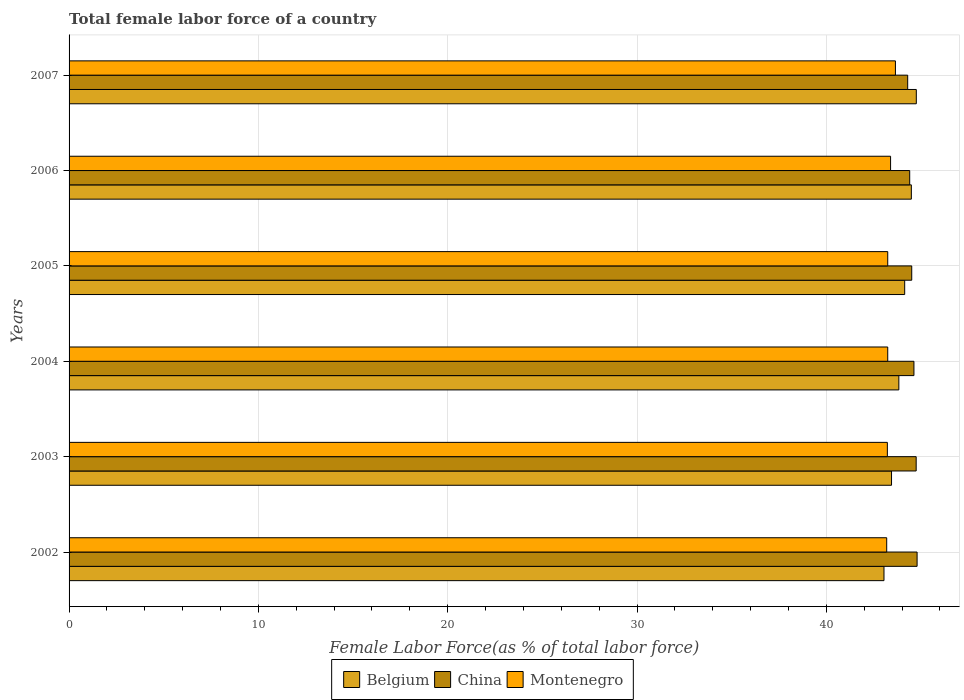How many different coloured bars are there?
Your answer should be very brief. 3. How many bars are there on the 1st tick from the bottom?
Offer a terse response. 3. What is the label of the 4th group of bars from the top?
Your response must be concise. 2004. In how many cases, is the number of bars for a given year not equal to the number of legend labels?
Your response must be concise. 0. What is the percentage of female labor force in China in 2002?
Your answer should be compact. 44.79. Across all years, what is the maximum percentage of female labor force in China?
Keep it short and to the point. 44.79. Across all years, what is the minimum percentage of female labor force in China?
Your answer should be compact. 44.3. In which year was the percentage of female labor force in Montenegro maximum?
Offer a terse response. 2007. In which year was the percentage of female labor force in Montenegro minimum?
Your answer should be very brief. 2002. What is the total percentage of female labor force in Montenegro in the graph?
Give a very brief answer. 259.93. What is the difference between the percentage of female labor force in Belgium in 2006 and that in 2007?
Offer a very short reply. -0.26. What is the difference between the percentage of female labor force in China in 2005 and the percentage of female labor force in Belgium in 2007?
Provide a succinct answer. -0.24. What is the average percentage of female labor force in China per year?
Your response must be concise. 44.56. In the year 2007, what is the difference between the percentage of female labor force in Montenegro and percentage of female labor force in Belgium?
Your response must be concise. -1.1. In how many years, is the percentage of female labor force in Belgium greater than 38 %?
Keep it short and to the point. 6. What is the ratio of the percentage of female labor force in Montenegro in 2002 to that in 2003?
Offer a very short reply. 1. What is the difference between the highest and the second highest percentage of female labor force in Belgium?
Offer a very short reply. 0.26. What is the difference between the highest and the lowest percentage of female labor force in Belgium?
Your answer should be very brief. 1.71. What does the 3rd bar from the top in 2006 represents?
Give a very brief answer. Belgium. How many bars are there?
Your response must be concise. 18. Are all the bars in the graph horizontal?
Make the answer very short. Yes. How many years are there in the graph?
Your answer should be very brief. 6. Are the values on the major ticks of X-axis written in scientific E-notation?
Ensure brevity in your answer.  No. How are the legend labels stacked?
Your answer should be compact. Horizontal. What is the title of the graph?
Make the answer very short. Total female labor force of a country. What is the label or title of the X-axis?
Give a very brief answer. Female Labor Force(as % of total labor force). What is the Female Labor Force(as % of total labor force) in Belgium in 2002?
Your response must be concise. 43.04. What is the Female Labor Force(as % of total labor force) of China in 2002?
Ensure brevity in your answer.  44.79. What is the Female Labor Force(as % of total labor force) in Montenegro in 2002?
Offer a very short reply. 43.19. What is the Female Labor Force(as % of total labor force) in Belgium in 2003?
Make the answer very short. 43.44. What is the Female Labor Force(as % of total labor force) of China in 2003?
Offer a terse response. 44.74. What is the Female Labor Force(as % of total labor force) of Montenegro in 2003?
Provide a short and direct response. 43.22. What is the Female Labor Force(as % of total labor force) in Belgium in 2004?
Make the answer very short. 43.83. What is the Female Labor Force(as % of total labor force) in China in 2004?
Provide a succinct answer. 44.63. What is the Female Labor Force(as % of total labor force) in Montenegro in 2004?
Ensure brevity in your answer.  43.24. What is the Female Labor Force(as % of total labor force) in Belgium in 2005?
Offer a terse response. 44.14. What is the Female Labor Force(as % of total labor force) in China in 2005?
Keep it short and to the point. 44.51. What is the Female Labor Force(as % of total labor force) of Montenegro in 2005?
Give a very brief answer. 43.24. What is the Female Labor Force(as % of total labor force) in Belgium in 2006?
Give a very brief answer. 44.49. What is the Female Labor Force(as % of total labor force) in China in 2006?
Provide a succinct answer. 44.4. What is the Female Labor Force(as % of total labor force) of Montenegro in 2006?
Your response must be concise. 43.39. What is the Female Labor Force(as % of total labor force) in Belgium in 2007?
Your answer should be compact. 44.75. What is the Female Labor Force(as % of total labor force) of China in 2007?
Your answer should be very brief. 44.3. What is the Female Labor Force(as % of total labor force) of Montenegro in 2007?
Provide a succinct answer. 43.65. Across all years, what is the maximum Female Labor Force(as % of total labor force) of Belgium?
Make the answer very short. 44.75. Across all years, what is the maximum Female Labor Force(as % of total labor force) in China?
Make the answer very short. 44.79. Across all years, what is the maximum Female Labor Force(as % of total labor force) in Montenegro?
Your answer should be very brief. 43.65. Across all years, what is the minimum Female Labor Force(as % of total labor force) of Belgium?
Your answer should be very brief. 43.04. Across all years, what is the minimum Female Labor Force(as % of total labor force) in China?
Keep it short and to the point. 44.3. Across all years, what is the minimum Female Labor Force(as % of total labor force) in Montenegro?
Provide a short and direct response. 43.19. What is the total Female Labor Force(as % of total labor force) of Belgium in the graph?
Give a very brief answer. 263.69. What is the total Female Labor Force(as % of total labor force) in China in the graph?
Provide a succinct answer. 267.37. What is the total Female Labor Force(as % of total labor force) of Montenegro in the graph?
Offer a very short reply. 259.93. What is the difference between the Female Labor Force(as % of total labor force) of Belgium in 2002 and that in 2003?
Offer a very short reply. -0.4. What is the difference between the Female Labor Force(as % of total labor force) of China in 2002 and that in 2003?
Keep it short and to the point. 0.05. What is the difference between the Female Labor Force(as % of total labor force) in Montenegro in 2002 and that in 2003?
Provide a short and direct response. -0.04. What is the difference between the Female Labor Force(as % of total labor force) in Belgium in 2002 and that in 2004?
Provide a succinct answer. -0.78. What is the difference between the Female Labor Force(as % of total labor force) of China in 2002 and that in 2004?
Your answer should be very brief. 0.17. What is the difference between the Female Labor Force(as % of total labor force) of Montenegro in 2002 and that in 2004?
Provide a succinct answer. -0.06. What is the difference between the Female Labor Force(as % of total labor force) in Belgium in 2002 and that in 2005?
Your answer should be very brief. -1.09. What is the difference between the Female Labor Force(as % of total labor force) in China in 2002 and that in 2005?
Provide a succinct answer. 0.28. What is the difference between the Female Labor Force(as % of total labor force) in Montenegro in 2002 and that in 2005?
Make the answer very short. -0.06. What is the difference between the Female Labor Force(as % of total labor force) of Belgium in 2002 and that in 2006?
Offer a very short reply. -1.45. What is the difference between the Female Labor Force(as % of total labor force) of China in 2002 and that in 2006?
Provide a short and direct response. 0.39. What is the difference between the Female Labor Force(as % of total labor force) of Montenegro in 2002 and that in 2006?
Give a very brief answer. -0.21. What is the difference between the Female Labor Force(as % of total labor force) in Belgium in 2002 and that in 2007?
Provide a short and direct response. -1.71. What is the difference between the Female Labor Force(as % of total labor force) of China in 2002 and that in 2007?
Offer a terse response. 0.5. What is the difference between the Female Labor Force(as % of total labor force) of Montenegro in 2002 and that in 2007?
Your response must be concise. -0.46. What is the difference between the Female Labor Force(as % of total labor force) in Belgium in 2003 and that in 2004?
Ensure brevity in your answer.  -0.39. What is the difference between the Female Labor Force(as % of total labor force) in China in 2003 and that in 2004?
Your answer should be very brief. 0.12. What is the difference between the Female Labor Force(as % of total labor force) in Montenegro in 2003 and that in 2004?
Offer a terse response. -0.02. What is the difference between the Female Labor Force(as % of total labor force) of Belgium in 2003 and that in 2005?
Ensure brevity in your answer.  -0.69. What is the difference between the Female Labor Force(as % of total labor force) of China in 2003 and that in 2005?
Provide a short and direct response. 0.23. What is the difference between the Female Labor Force(as % of total labor force) in Montenegro in 2003 and that in 2005?
Give a very brief answer. -0.02. What is the difference between the Female Labor Force(as % of total labor force) of Belgium in 2003 and that in 2006?
Your answer should be compact. -1.05. What is the difference between the Female Labor Force(as % of total labor force) in China in 2003 and that in 2006?
Ensure brevity in your answer.  0.34. What is the difference between the Female Labor Force(as % of total labor force) of Montenegro in 2003 and that in 2006?
Ensure brevity in your answer.  -0.17. What is the difference between the Female Labor Force(as % of total labor force) of Belgium in 2003 and that in 2007?
Provide a short and direct response. -1.31. What is the difference between the Female Labor Force(as % of total labor force) of China in 2003 and that in 2007?
Provide a short and direct response. 0.45. What is the difference between the Female Labor Force(as % of total labor force) of Montenegro in 2003 and that in 2007?
Your answer should be very brief. -0.43. What is the difference between the Female Labor Force(as % of total labor force) in Belgium in 2004 and that in 2005?
Provide a succinct answer. -0.31. What is the difference between the Female Labor Force(as % of total labor force) of China in 2004 and that in 2005?
Offer a very short reply. 0.12. What is the difference between the Female Labor Force(as % of total labor force) of Belgium in 2004 and that in 2006?
Make the answer very short. -0.66. What is the difference between the Female Labor Force(as % of total labor force) of China in 2004 and that in 2006?
Make the answer very short. 0.22. What is the difference between the Female Labor Force(as % of total labor force) in Montenegro in 2004 and that in 2006?
Offer a very short reply. -0.15. What is the difference between the Female Labor Force(as % of total labor force) of Belgium in 2004 and that in 2007?
Keep it short and to the point. -0.92. What is the difference between the Female Labor Force(as % of total labor force) of China in 2004 and that in 2007?
Provide a succinct answer. 0.33. What is the difference between the Female Labor Force(as % of total labor force) of Montenegro in 2004 and that in 2007?
Give a very brief answer. -0.41. What is the difference between the Female Labor Force(as % of total labor force) in Belgium in 2005 and that in 2006?
Give a very brief answer. -0.35. What is the difference between the Female Labor Force(as % of total labor force) in China in 2005 and that in 2006?
Keep it short and to the point. 0.11. What is the difference between the Female Labor Force(as % of total labor force) of Montenegro in 2005 and that in 2006?
Provide a short and direct response. -0.15. What is the difference between the Female Labor Force(as % of total labor force) in Belgium in 2005 and that in 2007?
Your answer should be compact. -0.61. What is the difference between the Female Labor Force(as % of total labor force) in China in 2005 and that in 2007?
Keep it short and to the point. 0.21. What is the difference between the Female Labor Force(as % of total labor force) of Montenegro in 2005 and that in 2007?
Your answer should be very brief. -0.41. What is the difference between the Female Labor Force(as % of total labor force) of Belgium in 2006 and that in 2007?
Provide a succinct answer. -0.26. What is the difference between the Female Labor Force(as % of total labor force) of China in 2006 and that in 2007?
Provide a short and direct response. 0.11. What is the difference between the Female Labor Force(as % of total labor force) of Montenegro in 2006 and that in 2007?
Ensure brevity in your answer.  -0.26. What is the difference between the Female Labor Force(as % of total labor force) in Belgium in 2002 and the Female Labor Force(as % of total labor force) in China in 2003?
Your answer should be very brief. -1.7. What is the difference between the Female Labor Force(as % of total labor force) of Belgium in 2002 and the Female Labor Force(as % of total labor force) of Montenegro in 2003?
Ensure brevity in your answer.  -0.18. What is the difference between the Female Labor Force(as % of total labor force) of China in 2002 and the Female Labor Force(as % of total labor force) of Montenegro in 2003?
Your response must be concise. 1.57. What is the difference between the Female Labor Force(as % of total labor force) in Belgium in 2002 and the Female Labor Force(as % of total labor force) in China in 2004?
Ensure brevity in your answer.  -1.58. What is the difference between the Female Labor Force(as % of total labor force) of Belgium in 2002 and the Female Labor Force(as % of total labor force) of Montenegro in 2004?
Ensure brevity in your answer.  -0.2. What is the difference between the Female Labor Force(as % of total labor force) of China in 2002 and the Female Labor Force(as % of total labor force) of Montenegro in 2004?
Give a very brief answer. 1.55. What is the difference between the Female Labor Force(as % of total labor force) of Belgium in 2002 and the Female Labor Force(as % of total labor force) of China in 2005?
Your answer should be very brief. -1.47. What is the difference between the Female Labor Force(as % of total labor force) of Belgium in 2002 and the Female Labor Force(as % of total labor force) of Montenegro in 2005?
Your response must be concise. -0.2. What is the difference between the Female Labor Force(as % of total labor force) in China in 2002 and the Female Labor Force(as % of total labor force) in Montenegro in 2005?
Offer a terse response. 1.55. What is the difference between the Female Labor Force(as % of total labor force) in Belgium in 2002 and the Female Labor Force(as % of total labor force) in China in 2006?
Your response must be concise. -1.36. What is the difference between the Female Labor Force(as % of total labor force) in Belgium in 2002 and the Female Labor Force(as % of total labor force) in Montenegro in 2006?
Keep it short and to the point. -0.35. What is the difference between the Female Labor Force(as % of total labor force) of Belgium in 2002 and the Female Labor Force(as % of total labor force) of China in 2007?
Ensure brevity in your answer.  -1.25. What is the difference between the Female Labor Force(as % of total labor force) of Belgium in 2002 and the Female Labor Force(as % of total labor force) of Montenegro in 2007?
Keep it short and to the point. -0.6. What is the difference between the Female Labor Force(as % of total labor force) in China in 2002 and the Female Labor Force(as % of total labor force) in Montenegro in 2007?
Give a very brief answer. 1.14. What is the difference between the Female Labor Force(as % of total labor force) of Belgium in 2003 and the Female Labor Force(as % of total labor force) of China in 2004?
Offer a terse response. -1.18. What is the difference between the Female Labor Force(as % of total labor force) in Belgium in 2003 and the Female Labor Force(as % of total labor force) in Montenegro in 2004?
Give a very brief answer. 0.2. What is the difference between the Female Labor Force(as % of total labor force) of China in 2003 and the Female Labor Force(as % of total labor force) of Montenegro in 2004?
Ensure brevity in your answer.  1.5. What is the difference between the Female Labor Force(as % of total labor force) in Belgium in 2003 and the Female Labor Force(as % of total labor force) in China in 2005?
Ensure brevity in your answer.  -1.07. What is the difference between the Female Labor Force(as % of total labor force) in Belgium in 2003 and the Female Labor Force(as % of total labor force) in Montenegro in 2005?
Your answer should be compact. 0.2. What is the difference between the Female Labor Force(as % of total labor force) in China in 2003 and the Female Labor Force(as % of total labor force) in Montenegro in 2005?
Give a very brief answer. 1.5. What is the difference between the Female Labor Force(as % of total labor force) in Belgium in 2003 and the Female Labor Force(as % of total labor force) in China in 2006?
Make the answer very short. -0.96. What is the difference between the Female Labor Force(as % of total labor force) in Belgium in 2003 and the Female Labor Force(as % of total labor force) in Montenegro in 2006?
Give a very brief answer. 0.05. What is the difference between the Female Labor Force(as % of total labor force) in China in 2003 and the Female Labor Force(as % of total labor force) in Montenegro in 2006?
Keep it short and to the point. 1.35. What is the difference between the Female Labor Force(as % of total labor force) of Belgium in 2003 and the Female Labor Force(as % of total labor force) of China in 2007?
Your answer should be compact. -0.85. What is the difference between the Female Labor Force(as % of total labor force) in Belgium in 2003 and the Female Labor Force(as % of total labor force) in Montenegro in 2007?
Give a very brief answer. -0.21. What is the difference between the Female Labor Force(as % of total labor force) in China in 2003 and the Female Labor Force(as % of total labor force) in Montenegro in 2007?
Your answer should be compact. 1.1. What is the difference between the Female Labor Force(as % of total labor force) in Belgium in 2004 and the Female Labor Force(as % of total labor force) in China in 2005?
Keep it short and to the point. -0.68. What is the difference between the Female Labor Force(as % of total labor force) of Belgium in 2004 and the Female Labor Force(as % of total labor force) of Montenegro in 2005?
Offer a terse response. 0.59. What is the difference between the Female Labor Force(as % of total labor force) of China in 2004 and the Female Labor Force(as % of total labor force) of Montenegro in 2005?
Offer a terse response. 1.38. What is the difference between the Female Labor Force(as % of total labor force) in Belgium in 2004 and the Female Labor Force(as % of total labor force) in China in 2006?
Provide a short and direct response. -0.57. What is the difference between the Female Labor Force(as % of total labor force) of Belgium in 2004 and the Female Labor Force(as % of total labor force) of Montenegro in 2006?
Ensure brevity in your answer.  0.44. What is the difference between the Female Labor Force(as % of total labor force) in China in 2004 and the Female Labor Force(as % of total labor force) in Montenegro in 2006?
Give a very brief answer. 1.23. What is the difference between the Female Labor Force(as % of total labor force) of Belgium in 2004 and the Female Labor Force(as % of total labor force) of China in 2007?
Your answer should be compact. -0.47. What is the difference between the Female Labor Force(as % of total labor force) in Belgium in 2004 and the Female Labor Force(as % of total labor force) in Montenegro in 2007?
Your answer should be very brief. 0.18. What is the difference between the Female Labor Force(as % of total labor force) in Belgium in 2005 and the Female Labor Force(as % of total labor force) in China in 2006?
Your response must be concise. -0.26. What is the difference between the Female Labor Force(as % of total labor force) of Belgium in 2005 and the Female Labor Force(as % of total labor force) of Montenegro in 2006?
Provide a succinct answer. 0.74. What is the difference between the Female Labor Force(as % of total labor force) of China in 2005 and the Female Labor Force(as % of total labor force) of Montenegro in 2006?
Provide a succinct answer. 1.12. What is the difference between the Female Labor Force(as % of total labor force) of Belgium in 2005 and the Female Labor Force(as % of total labor force) of China in 2007?
Your response must be concise. -0.16. What is the difference between the Female Labor Force(as % of total labor force) in Belgium in 2005 and the Female Labor Force(as % of total labor force) in Montenegro in 2007?
Your answer should be compact. 0.49. What is the difference between the Female Labor Force(as % of total labor force) in China in 2005 and the Female Labor Force(as % of total labor force) in Montenegro in 2007?
Give a very brief answer. 0.86. What is the difference between the Female Labor Force(as % of total labor force) in Belgium in 2006 and the Female Labor Force(as % of total labor force) in China in 2007?
Ensure brevity in your answer.  0.19. What is the difference between the Female Labor Force(as % of total labor force) in Belgium in 2006 and the Female Labor Force(as % of total labor force) in Montenegro in 2007?
Your answer should be very brief. 0.84. What is the difference between the Female Labor Force(as % of total labor force) in China in 2006 and the Female Labor Force(as % of total labor force) in Montenegro in 2007?
Ensure brevity in your answer.  0.75. What is the average Female Labor Force(as % of total labor force) in Belgium per year?
Make the answer very short. 43.95. What is the average Female Labor Force(as % of total labor force) of China per year?
Offer a terse response. 44.56. What is the average Female Labor Force(as % of total labor force) in Montenegro per year?
Your response must be concise. 43.32. In the year 2002, what is the difference between the Female Labor Force(as % of total labor force) in Belgium and Female Labor Force(as % of total labor force) in China?
Your answer should be compact. -1.75. In the year 2002, what is the difference between the Female Labor Force(as % of total labor force) of Belgium and Female Labor Force(as % of total labor force) of Montenegro?
Your response must be concise. -0.14. In the year 2002, what is the difference between the Female Labor Force(as % of total labor force) in China and Female Labor Force(as % of total labor force) in Montenegro?
Provide a succinct answer. 1.61. In the year 2003, what is the difference between the Female Labor Force(as % of total labor force) of Belgium and Female Labor Force(as % of total labor force) of China?
Offer a terse response. -1.3. In the year 2003, what is the difference between the Female Labor Force(as % of total labor force) in Belgium and Female Labor Force(as % of total labor force) in Montenegro?
Your response must be concise. 0.22. In the year 2003, what is the difference between the Female Labor Force(as % of total labor force) in China and Female Labor Force(as % of total labor force) in Montenegro?
Offer a terse response. 1.52. In the year 2004, what is the difference between the Female Labor Force(as % of total labor force) in Belgium and Female Labor Force(as % of total labor force) in China?
Make the answer very short. -0.8. In the year 2004, what is the difference between the Female Labor Force(as % of total labor force) of Belgium and Female Labor Force(as % of total labor force) of Montenegro?
Ensure brevity in your answer.  0.59. In the year 2004, what is the difference between the Female Labor Force(as % of total labor force) in China and Female Labor Force(as % of total labor force) in Montenegro?
Offer a very short reply. 1.38. In the year 2005, what is the difference between the Female Labor Force(as % of total labor force) of Belgium and Female Labor Force(as % of total labor force) of China?
Your answer should be compact. -0.37. In the year 2005, what is the difference between the Female Labor Force(as % of total labor force) in Belgium and Female Labor Force(as % of total labor force) in Montenegro?
Offer a very short reply. 0.89. In the year 2005, what is the difference between the Female Labor Force(as % of total labor force) of China and Female Labor Force(as % of total labor force) of Montenegro?
Your answer should be compact. 1.27. In the year 2006, what is the difference between the Female Labor Force(as % of total labor force) of Belgium and Female Labor Force(as % of total labor force) of China?
Provide a short and direct response. 0.09. In the year 2006, what is the difference between the Female Labor Force(as % of total labor force) in Belgium and Female Labor Force(as % of total labor force) in Montenegro?
Keep it short and to the point. 1.1. In the year 2006, what is the difference between the Female Labor Force(as % of total labor force) in China and Female Labor Force(as % of total labor force) in Montenegro?
Give a very brief answer. 1.01. In the year 2007, what is the difference between the Female Labor Force(as % of total labor force) in Belgium and Female Labor Force(as % of total labor force) in China?
Offer a terse response. 0.46. In the year 2007, what is the difference between the Female Labor Force(as % of total labor force) in Belgium and Female Labor Force(as % of total labor force) in Montenegro?
Ensure brevity in your answer.  1.1. In the year 2007, what is the difference between the Female Labor Force(as % of total labor force) of China and Female Labor Force(as % of total labor force) of Montenegro?
Your answer should be compact. 0.65. What is the ratio of the Female Labor Force(as % of total labor force) in Belgium in 2002 to that in 2003?
Provide a short and direct response. 0.99. What is the ratio of the Female Labor Force(as % of total labor force) of China in 2002 to that in 2003?
Provide a succinct answer. 1. What is the ratio of the Female Labor Force(as % of total labor force) of Montenegro in 2002 to that in 2003?
Offer a terse response. 1. What is the ratio of the Female Labor Force(as % of total labor force) in Belgium in 2002 to that in 2004?
Give a very brief answer. 0.98. What is the ratio of the Female Labor Force(as % of total labor force) of Belgium in 2002 to that in 2005?
Provide a short and direct response. 0.98. What is the ratio of the Female Labor Force(as % of total labor force) of China in 2002 to that in 2005?
Your answer should be very brief. 1.01. What is the ratio of the Female Labor Force(as % of total labor force) in Belgium in 2002 to that in 2006?
Make the answer very short. 0.97. What is the ratio of the Female Labor Force(as % of total labor force) in China in 2002 to that in 2006?
Give a very brief answer. 1.01. What is the ratio of the Female Labor Force(as % of total labor force) of Belgium in 2002 to that in 2007?
Keep it short and to the point. 0.96. What is the ratio of the Female Labor Force(as % of total labor force) in China in 2002 to that in 2007?
Your answer should be compact. 1.01. What is the ratio of the Female Labor Force(as % of total labor force) in Montenegro in 2002 to that in 2007?
Make the answer very short. 0.99. What is the ratio of the Female Labor Force(as % of total labor force) of Belgium in 2003 to that in 2004?
Ensure brevity in your answer.  0.99. What is the ratio of the Female Labor Force(as % of total labor force) of Montenegro in 2003 to that in 2004?
Provide a short and direct response. 1. What is the ratio of the Female Labor Force(as % of total labor force) in Belgium in 2003 to that in 2005?
Keep it short and to the point. 0.98. What is the ratio of the Female Labor Force(as % of total labor force) in Montenegro in 2003 to that in 2005?
Your answer should be compact. 1. What is the ratio of the Female Labor Force(as % of total labor force) of Belgium in 2003 to that in 2006?
Provide a succinct answer. 0.98. What is the ratio of the Female Labor Force(as % of total labor force) of China in 2003 to that in 2006?
Your response must be concise. 1.01. What is the ratio of the Female Labor Force(as % of total labor force) in Montenegro in 2003 to that in 2006?
Keep it short and to the point. 1. What is the ratio of the Female Labor Force(as % of total labor force) of Belgium in 2003 to that in 2007?
Make the answer very short. 0.97. What is the ratio of the Female Labor Force(as % of total labor force) of China in 2003 to that in 2007?
Make the answer very short. 1.01. What is the ratio of the Female Labor Force(as % of total labor force) in Montenegro in 2003 to that in 2007?
Provide a short and direct response. 0.99. What is the ratio of the Female Labor Force(as % of total labor force) in Belgium in 2004 to that in 2005?
Provide a succinct answer. 0.99. What is the ratio of the Female Labor Force(as % of total labor force) of Montenegro in 2004 to that in 2005?
Your response must be concise. 1. What is the ratio of the Female Labor Force(as % of total labor force) in Belgium in 2004 to that in 2006?
Provide a succinct answer. 0.99. What is the ratio of the Female Labor Force(as % of total labor force) of China in 2004 to that in 2006?
Ensure brevity in your answer.  1. What is the ratio of the Female Labor Force(as % of total labor force) in Montenegro in 2004 to that in 2006?
Ensure brevity in your answer.  1. What is the ratio of the Female Labor Force(as % of total labor force) of Belgium in 2004 to that in 2007?
Ensure brevity in your answer.  0.98. What is the ratio of the Female Labor Force(as % of total labor force) in China in 2004 to that in 2007?
Offer a very short reply. 1.01. What is the ratio of the Female Labor Force(as % of total labor force) in Montenegro in 2004 to that in 2007?
Give a very brief answer. 0.99. What is the ratio of the Female Labor Force(as % of total labor force) of Belgium in 2005 to that in 2007?
Your response must be concise. 0.99. What is the ratio of the Female Labor Force(as % of total labor force) of China in 2005 to that in 2007?
Your answer should be very brief. 1. What is the ratio of the Female Labor Force(as % of total labor force) of China in 2006 to that in 2007?
Ensure brevity in your answer.  1. What is the ratio of the Female Labor Force(as % of total labor force) of Montenegro in 2006 to that in 2007?
Ensure brevity in your answer.  0.99. What is the difference between the highest and the second highest Female Labor Force(as % of total labor force) in Belgium?
Make the answer very short. 0.26. What is the difference between the highest and the second highest Female Labor Force(as % of total labor force) of China?
Your answer should be very brief. 0.05. What is the difference between the highest and the second highest Female Labor Force(as % of total labor force) of Montenegro?
Ensure brevity in your answer.  0.26. What is the difference between the highest and the lowest Female Labor Force(as % of total labor force) in Belgium?
Offer a terse response. 1.71. What is the difference between the highest and the lowest Female Labor Force(as % of total labor force) in China?
Provide a short and direct response. 0.5. What is the difference between the highest and the lowest Female Labor Force(as % of total labor force) in Montenegro?
Your answer should be very brief. 0.46. 